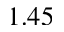Convert formula to latex. <formula><loc_0><loc_0><loc_500><loc_500>1 . 4 5</formula> 